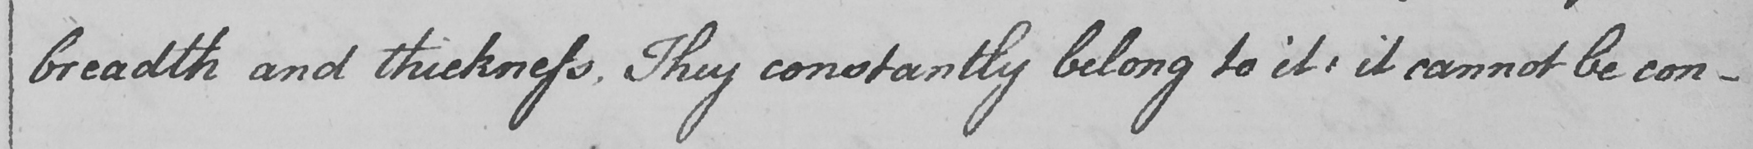Please provide the text content of this handwritten line. breadth and thickness . They constantly belong to it :  it cannot be con- 